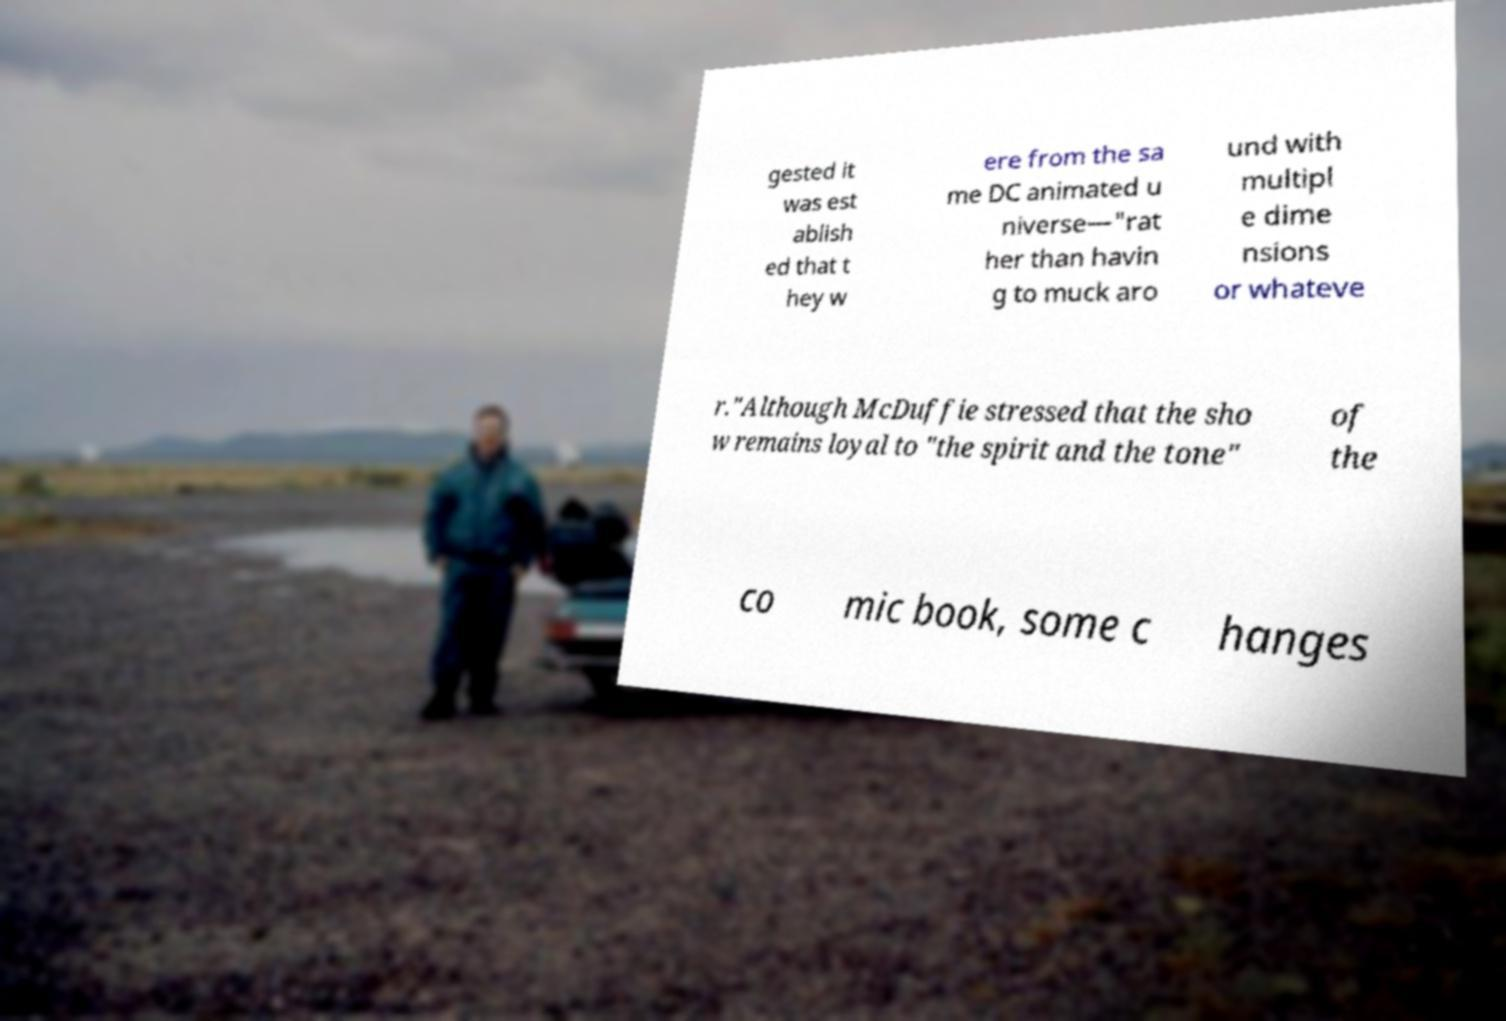There's text embedded in this image that I need extracted. Can you transcribe it verbatim? gested it was est ablish ed that t hey w ere from the sa me DC animated u niverse—"rat her than havin g to muck aro und with multipl e dime nsions or whateve r."Although McDuffie stressed that the sho w remains loyal to "the spirit and the tone" of the co mic book, some c hanges 